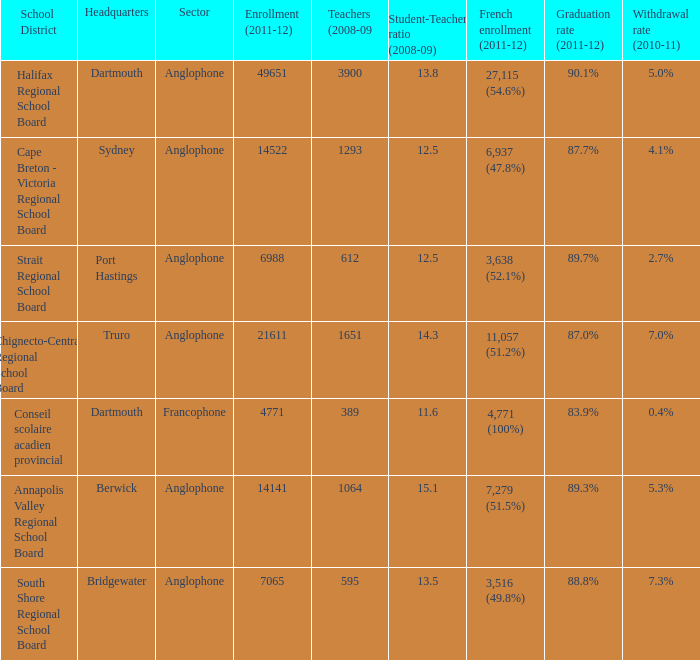What is the withdrawal rate for the school district with a graduation rate of 89.3%? 5.3%. Could you parse the entire table as a dict? {'header': ['School District', 'Headquarters', 'Sector', 'Enrollment (2011-12)', 'Teachers (2008-09', 'Student-Teacher ratio (2008-09)', 'French enrollment (2011-12)', 'Graduation rate (2011-12)', 'Withdrawal rate (2010-11)'], 'rows': [['Halifax Regional School Board', 'Dartmouth', 'Anglophone', '49651', '3900', '13.8', '27,115 (54.6%)', '90.1%', '5.0%'], ['Cape Breton - Victoria Regional School Board', 'Sydney', 'Anglophone', '14522', '1293', '12.5', '6,937 (47.8%)', '87.7%', '4.1%'], ['Strait Regional School Board', 'Port Hastings', 'Anglophone', '6988', '612', '12.5', '3,638 (52.1%)', '89.7%', '2.7%'], ['Chignecto-Central Regional School Board', 'Truro', 'Anglophone', '21611', '1651', '14.3', '11,057 (51.2%)', '87.0%', '7.0%'], ['Conseil scolaire acadien provincial', 'Dartmouth', 'Francophone', '4771', '389', '11.6', '4,771 (100%)', '83.9%', '0.4%'], ['Annapolis Valley Regional School Board', 'Berwick', 'Anglophone', '14141', '1064', '15.1', '7,279 (51.5%)', '89.3%', '5.3%'], ['South Shore Regional School Board', 'Bridgewater', 'Anglophone', '7065', '595', '13.5', '3,516 (49.8%)', '88.8%', '7.3%']]} 